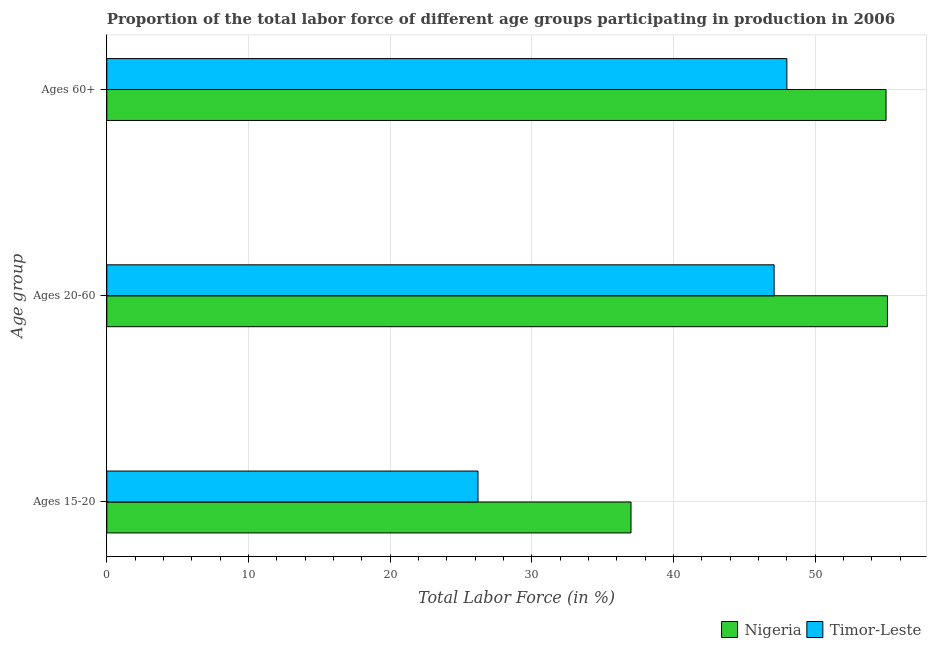Are the number of bars on each tick of the Y-axis equal?
Ensure brevity in your answer.  Yes. How many bars are there on the 3rd tick from the top?
Keep it short and to the point. 2. What is the label of the 1st group of bars from the top?
Keep it short and to the point. Ages 60+. Across all countries, what is the maximum percentage of labor force within the age group 15-20?
Provide a succinct answer. 37. Across all countries, what is the minimum percentage of labor force above age 60?
Provide a short and direct response. 48. In which country was the percentage of labor force within the age group 15-20 maximum?
Offer a very short reply. Nigeria. In which country was the percentage of labor force within the age group 15-20 minimum?
Provide a short and direct response. Timor-Leste. What is the total percentage of labor force within the age group 15-20 in the graph?
Your answer should be compact. 63.2. What is the difference between the percentage of labor force above age 60 in Timor-Leste and that in Nigeria?
Offer a terse response. -7. What is the difference between the percentage of labor force within the age group 20-60 in Nigeria and the percentage of labor force above age 60 in Timor-Leste?
Offer a terse response. 7.1. What is the average percentage of labor force within the age group 20-60 per country?
Provide a short and direct response. 51.1. What is the difference between the percentage of labor force above age 60 and percentage of labor force within the age group 15-20 in Timor-Leste?
Your answer should be very brief. 21.8. What is the ratio of the percentage of labor force above age 60 in Nigeria to that in Timor-Leste?
Your response must be concise. 1.15. Is the percentage of labor force above age 60 in Nigeria less than that in Timor-Leste?
Give a very brief answer. No. What is the difference between the highest and the second highest percentage of labor force within the age group 15-20?
Provide a succinct answer. 10.8. What is the difference between the highest and the lowest percentage of labor force within the age group 20-60?
Offer a very short reply. 8. Is the sum of the percentage of labor force within the age group 20-60 in Timor-Leste and Nigeria greater than the maximum percentage of labor force above age 60 across all countries?
Keep it short and to the point. Yes. What does the 2nd bar from the top in Ages 60+ represents?
Provide a short and direct response. Nigeria. What does the 1st bar from the bottom in Ages 60+ represents?
Make the answer very short. Nigeria. Is it the case that in every country, the sum of the percentage of labor force within the age group 15-20 and percentage of labor force within the age group 20-60 is greater than the percentage of labor force above age 60?
Ensure brevity in your answer.  Yes. How many bars are there?
Your answer should be compact. 6. Are all the bars in the graph horizontal?
Offer a terse response. Yes. How many countries are there in the graph?
Keep it short and to the point. 2. Are the values on the major ticks of X-axis written in scientific E-notation?
Your response must be concise. No. Where does the legend appear in the graph?
Offer a terse response. Bottom right. What is the title of the graph?
Make the answer very short. Proportion of the total labor force of different age groups participating in production in 2006. What is the label or title of the Y-axis?
Give a very brief answer. Age group. What is the Total Labor Force (in %) in Timor-Leste in Ages 15-20?
Keep it short and to the point. 26.2. What is the Total Labor Force (in %) in Nigeria in Ages 20-60?
Give a very brief answer. 55.1. What is the Total Labor Force (in %) in Timor-Leste in Ages 20-60?
Your response must be concise. 47.1. What is the Total Labor Force (in %) in Timor-Leste in Ages 60+?
Make the answer very short. 48. Across all Age group, what is the maximum Total Labor Force (in %) of Nigeria?
Give a very brief answer. 55.1. Across all Age group, what is the minimum Total Labor Force (in %) in Timor-Leste?
Make the answer very short. 26.2. What is the total Total Labor Force (in %) in Nigeria in the graph?
Offer a terse response. 147.1. What is the total Total Labor Force (in %) of Timor-Leste in the graph?
Give a very brief answer. 121.3. What is the difference between the Total Labor Force (in %) in Nigeria in Ages 15-20 and that in Ages 20-60?
Your answer should be compact. -18.1. What is the difference between the Total Labor Force (in %) in Timor-Leste in Ages 15-20 and that in Ages 20-60?
Your answer should be very brief. -20.9. What is the difference between the Total Labor Force (in %) in Timor-Leste in Ages 15-20 and that in Ages 60+?
Offer a terse response. -21.8. What is the difference between the Total Labor Force (in %) of Nigeria in Ages 15-20 and the Total Labor Force (in %) of Timor-Leste in Ages 20-60?
Your answer should be compact. -10.1. What is the difference between the Total Labor Force (in %) in Nigeria in Ages 20-60 and the Total Labor Force (in %) in Timor-Leste in Ages 60+?
Offer a very short reply. 7.1. What is the average Total Labor Force (in %) in Nigeria per Age group?
Your answer should be compact. 49.03. What is the average Total Labor Force (in %) of Timor-Leste per Age group?
Your answer should be very brief. 40.43. What is the difference between the Total Labor Force (in %) in Nigeria and Total Labor Force (in %) in Timor-Leste in Ages 60+?
Keep it short and to the point. 7. What is the ratio of the Total Labor Force (in %) in Nigeria in Ages 15-20 to that in Ages 20-60?
Ensure brevity in your answer.  0.67. What is the ratio of the Total Labor Force (in %) in Timor-Leste in Ages 15-20 to that in Ages 20-60?
Your answer should be very brief. 0.56. What is the ratio of the Total Labor Force (in %) in Nigeria in Ages 15-20 to that in Ages 60+?
Make the answer very short. 0.67. What is the ratio of the Total Labor Force (in %) of Timor-Leste in Ages 15-20 to that in Ages 60+?
Your answer should be compact. 0.55. What is the ratio of the Total Labor Force (in %) in Timor-Leste in Ages 20-60 to that in Ages 60+?
Your answer should be compact. 0.98. What is the difference between the highest and the second highest Total Labor Force (in %) in Timor-Leste?
Offer a terse response. 0.9. What is the difference between the highest and the lowest Total Labor Force (in %) in Nigeria?
Ensure brevity in your answer.  18.1. What is the difference between the highest and the lowest Total Labor Force (in %) in Timor-Leste?
Offer a very short reply. 21.8. 